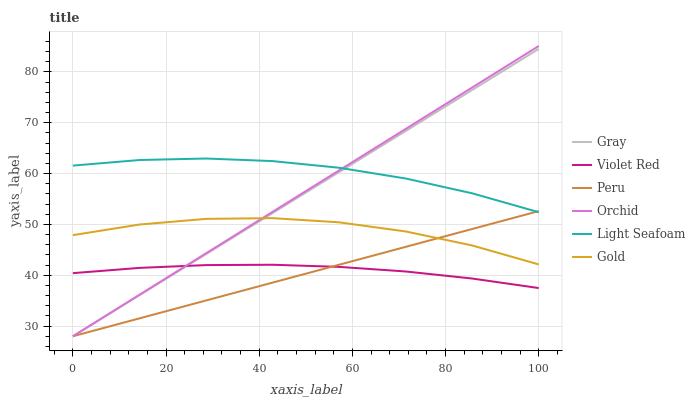Does Peru have the minimum area under the curve?
Answer yes or no. Yes. Does Light Seafoam have the maximum area under the curve?
Answer yes or no. Yes. Does Violet Red have the minimum area under the curve?
Answer yes or no. No. Does Violet Red have the maximum area under the curve?
Answer yes or no. No. Is Gray the smoothest?
Answer yes or no. Yes. Is Gold the roughest?
Answer yes or no. Yes. Is Violet Red the smoothest?
Answer yes or no. No. Is Violet Red the roughest?
Answer yes or no. No. Does Gray have the lowest value?
Answer yes or no. Yes. Does Violet Red have the lowest value?
Answer yes or no. No. Does Orchid have the highest value?
Answer yes or no. Yes. Does Gold have the highest value?
Answer yes or no. No. Is Violet Red less than Light Seafoam?
Answer yes or no. Yes. Is Light Seafoam greater than Gold?
Answer yes or no. Yes. Does Peru intersect Violet Red?
Answer yes or no. Yes. Is Peru less than Violet Red?
Answer yes or no. No. Is Peru greater than Violet Red?
Answer yes or no. No. Does Violet Red intersect Light Seafoam?
Answer yes or no. No. 